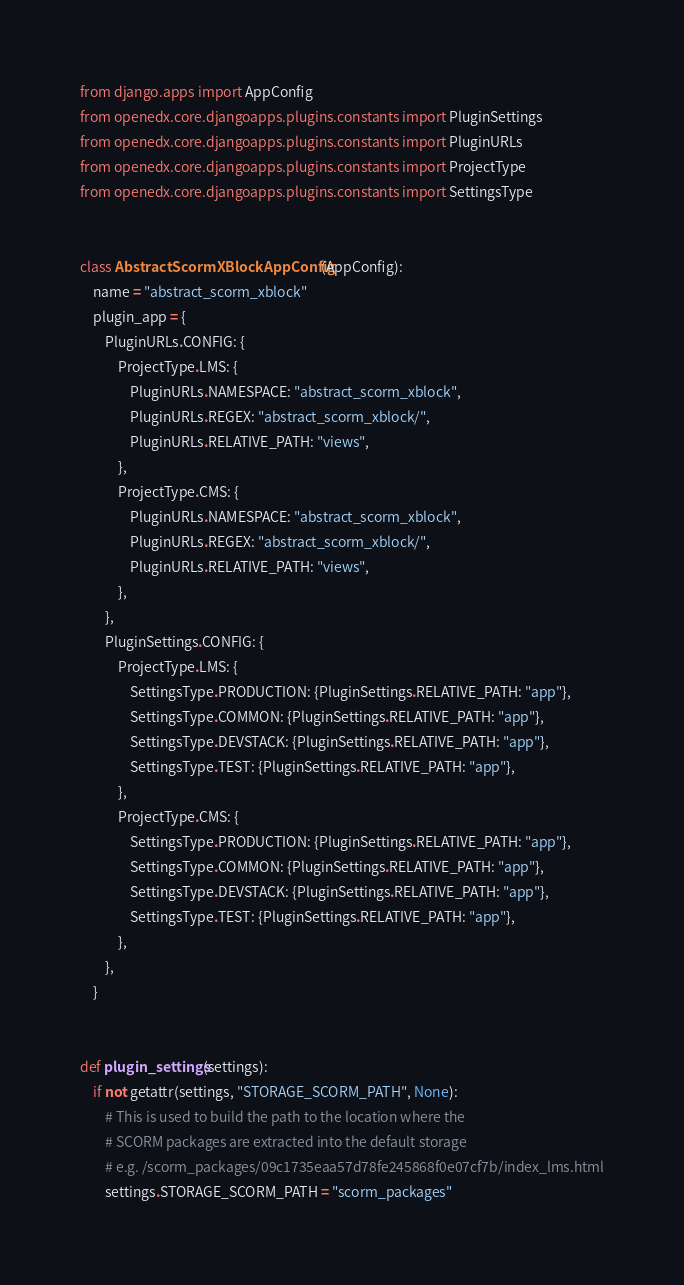<code> <loc_0><loc_0><loc_500><loc_500><_Python_>from django.apps import AppConfig
from openedx.core.djangoapps.plugins.constants import PluginSettings
from openedx.core.djangoapps.plugins.constants import PluginURLs
from openedx.core.djangoapps.plugins.constants import ProjectType
from openedx.core.djangoapps.plugins.constants import SettingsType


class AbstractScormXBlockAppConfig(AppConfig):
    name = "abstract_scorm_xblock"
    plugin_app = {
        PluginURLs.CONFIG: {
            ProjectType.LMS: {
                PluginURLs.NAMESPACE: "abstract_scorm_xblock",
                PluginURLs.REGEX: "abstract_scorm_xblock/",
                PluginURLs.RELATIVE_PATH: "views",
            },
            ProjectType.CMS: {
                PluginURLs.NAMESPACE: "abstract_scorm_xblock",
                PluginURLs.REGEX: "abstract_scorm_xblock/",
                PluginURLs.RELATIVE_PATH: "views",
            },
        },
        PluginSettings.CONFIG: {
            ProjectType.LMS: {
                SettingsType.PRODUCTION: {PluginSettings.RELATIVE_PATH: "app"},
                SettingsType.COMMON: {PluginSettings.RELATIVE_PATH: "app"},
                SettingsType.DEVSTACK: {PluginSettings.RELATIVE_PATH: "app"},
                SettingsType.TEST: {PluginSettings.RELATIVE_PATH: "app"},
            },
            ProjectType.CMS: {
                SettingsType.PRODUCTION: {PluginSettings.RELATIVE_PATH: "app"},
                SettingsType.COMMON: {PluginSettings.RELATIVE_PATH: "app"},
                SettingsType.DEVSTACK: {PluginSettings.RELATIVE_PATH: "app"},
                SettingsType.TEST: {PluginSettings.RELATIVE_PATH: "app"},
            },
        },
    }


def plugin_settings(settings):
    if not getattr(settings, "STORAGE_SCORM_PATH", None):
        # This is used to build the path to the location where the
        # SCORM packages are extracted into the default storage
        # e.g. /scorm_packages/09c1735eaa57d78fe245868f0e07cf7b/index_lms.html
        settings.STORAGE_SCORM_PATH = "scorm_packages"
</code> 